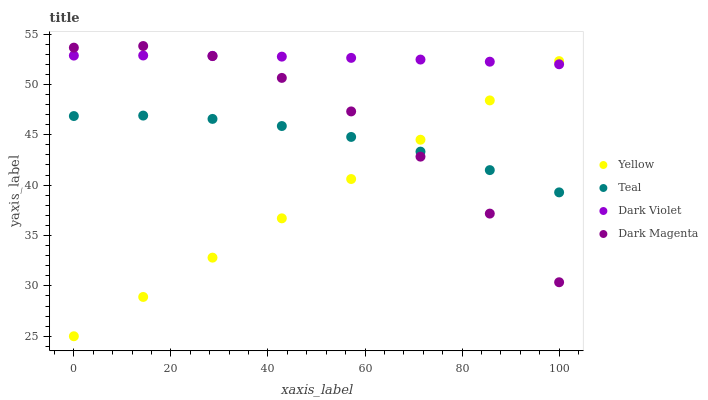Does Yellow have the minimum area under the curve?
Answer yes or no. Yes. Does Dark Violet have the maximum area under the curve?
Answer yes or no. Yes. Does Teal have the minimum area under the curve?
Answer yes or no. No. Does Teal have the maximum area under the curve?
Answer yes or no. No. Is Yellow the smoothest?
Answer yes or no. Yes. Is Dark Magenta the roughest?
Answer yes or no. Yes. Is Teal the smoothest?
Answer yes or no. No. Is Teal the roughest?
Answer yes or no. No. Does Yellow have the lowest value?
Answer yes or no. Yes. Does Teal have the lowest value?
Answer yes or no. No. Does Dark Magenta have the highest value?
Answer yes or no. Yes. Does Yellow have the highest value?
Answer yes or no. No. Is Teal less than Dark Violet?
Answer yes or no. Yes. Is Dark Violet greater than Teal?
Answer yes or no. Yes. Does Teal intersect Dark Magenta?
Answer yes or no. Yes. Is Teal less than Dark Magenta?
Answer yes or no. No. Is Teal greater than Dark Magenta?
Answer yes or no. No. Does Teal intersect Dark Violet?
Answer yes or no. No. 